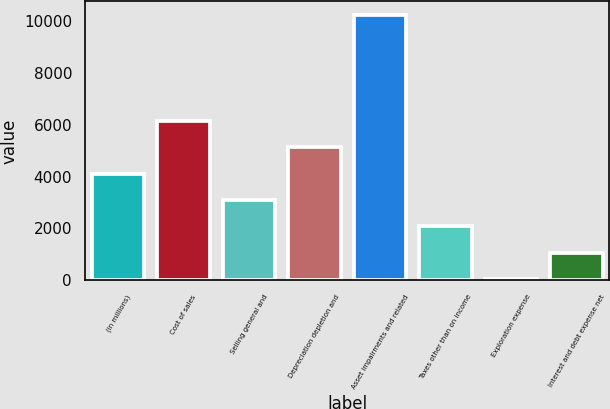Convert chart to OTSL. <chart><loc_0><loc_0><loc_500><loc_500><bar_chart><fcel>(in millions)<fcel>Cost of sales<fcel>Selling general and<fcel>Depreciation depletion and<fcel>Asset impairments and related<fcel>Taxes other than on income<fcel>Exploration expense<fcel>Interest and debt expense net<nl><fcel>4117.2<fcel>6157.8<fcel>3096.9<fcel>5137.5<fcel>10239<fcel>2076.6<fcel>36<fcel>1056.3<nl></chart> 